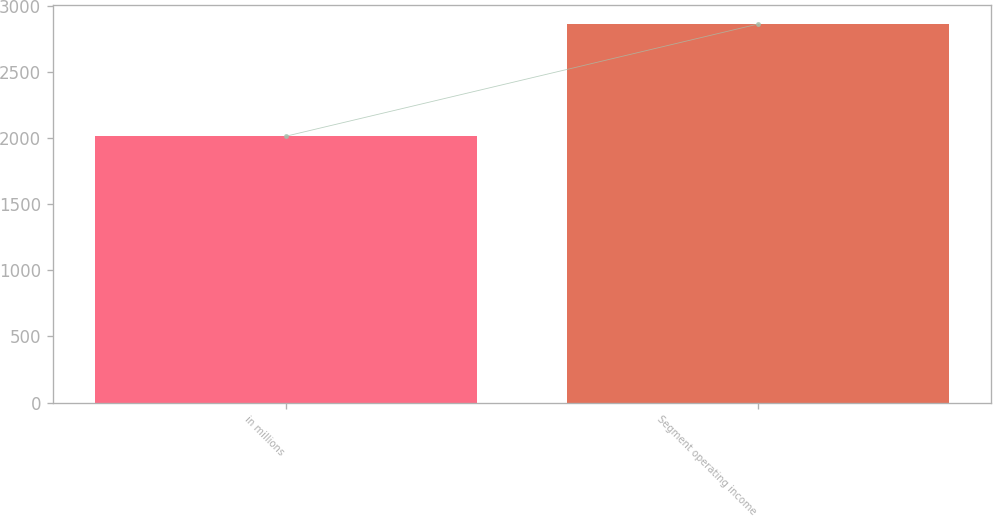<chart> <loc_0><loc_0><loc_500><loc_500><bar_chart><fcel>in millions<fcel>Segment operating income<nl><fcel>2016<fcel>2864<nl></chart> 